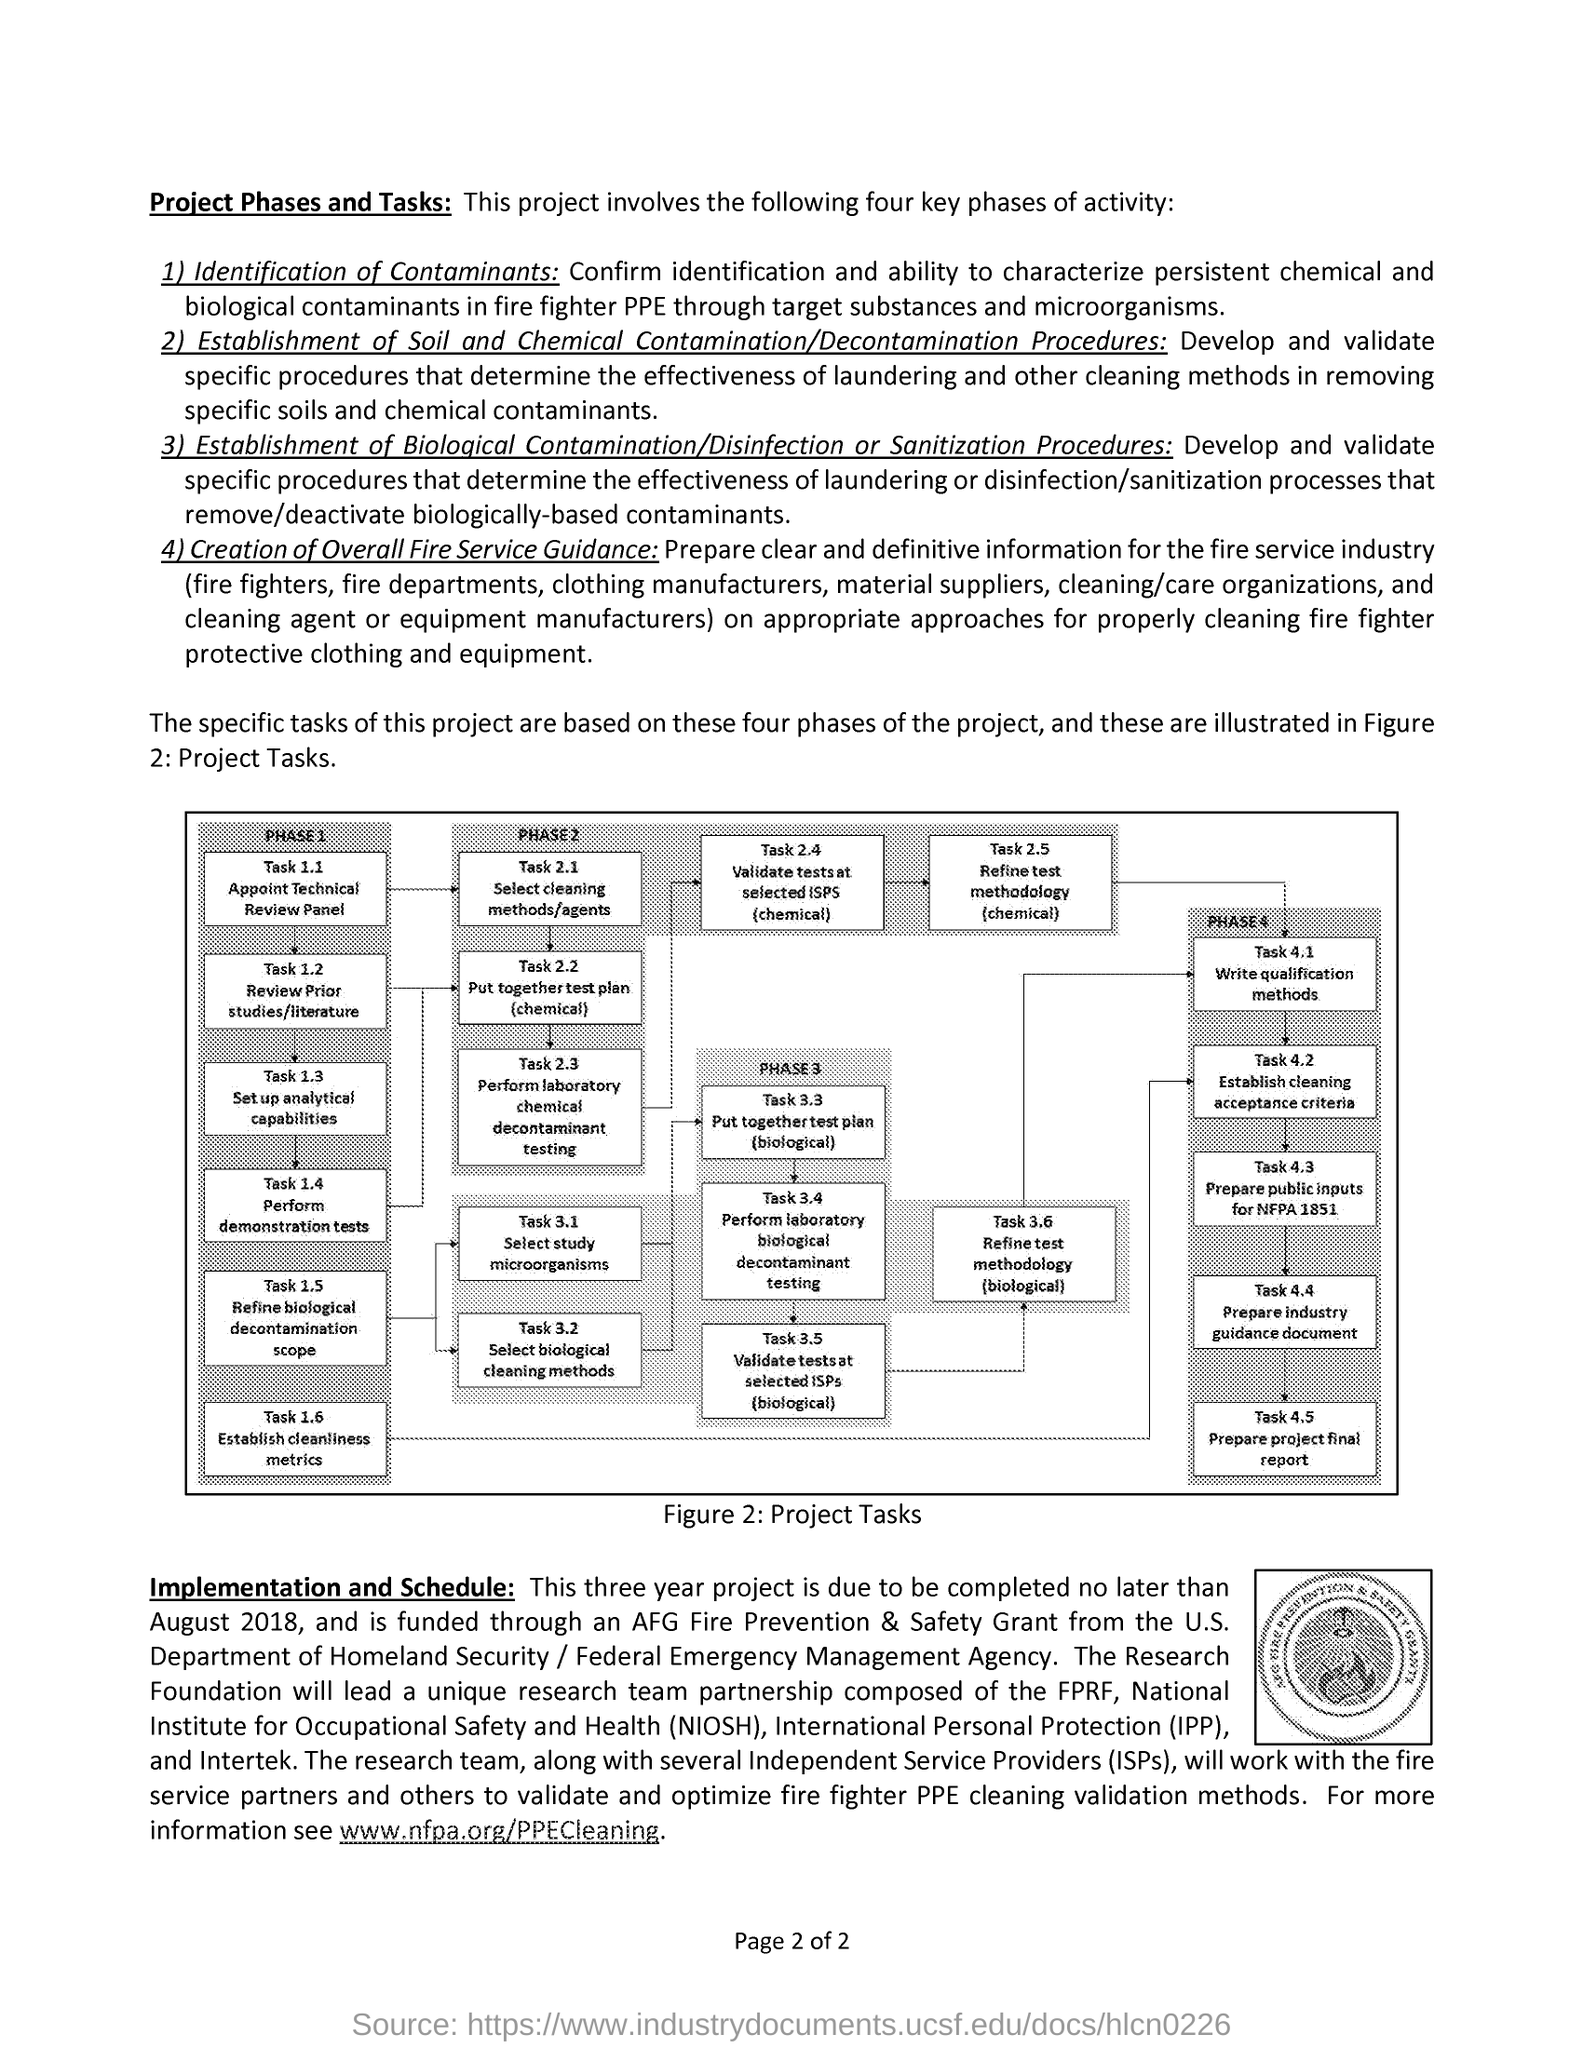What is mentioned in phase 1 task 1.2 ?
Provide a succinct answer. Review prior studies/literature. What is ipp stands for ?
Make the answer very short. International Personal Protection. What is niosh stands for ?
Your answer should be compact. National Institute for Occupational Safety and Health. What is mentioned in phase 3 task 3.3 ?
Ensure brevity in your answer.  Put together test plan (biological). 